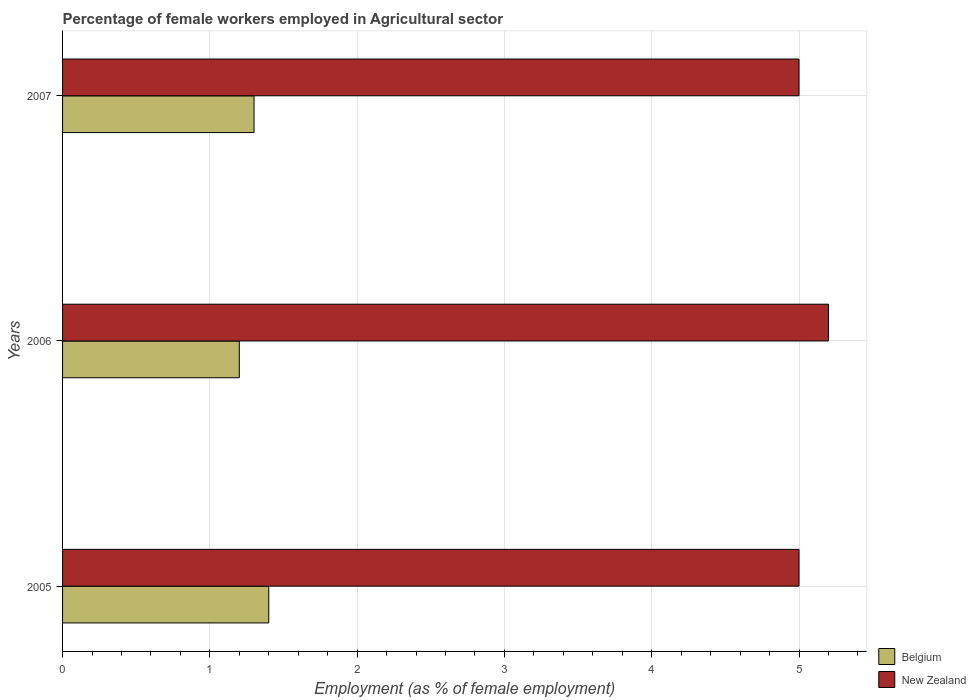How many groups of bars are there?
Keep it short and to the point. 3. Are the number of bars per tick equal to the number of legend labels?
Your answer should be very brief. Yes. Are the number of bars on each tick of the Y-axis equal?
Your answer should be compact. Yes. What is the label of the 1st group of bars from the top?
Offer a terse response. 2007. In how many cases, is the number of bars for a given year not equal to the number of legend labels?
Your answer should be very brief. 0. What is the percentage of females employed in Agricultural sector in Belgium in 2007?
Provide a succinct answer. 1.3. Across all years, what is the maximum percentage of females employed in Agricultural sector in New Zealand?
Your answer should be very brief. 5.2. Across all years, what is the minimum percentage of females employed in Agricultural sector in New Zealand?
Keep it short and to the point. 5. What is the total percentage of females employed in Agricultural sector in Belgium in the graph?
Keep it short and to the point. 3.9. What is the difference between the percentage of females employed in Agricultural sector in Belgium in 2006 and that in 2007?
Make the answer very short. -0.1. What is the difference between the percentage of females employed in Agricultural sector in Belgium in 2006 and the percentage of females employed in Agricultural sector in New Zealand in 2007?
Keep it short and to the point. -3.8. What is the average percentage of females employed in Agricultural sector in Belgium per year?
Provide a short and direct response. 1.3. In the year 2005, what is the difference between the percentage of females employed in Agricultural sector in New Zealand and percentage of females employed in Agricultural sector in Belgium?
Your answer should be compact. 3.6. What is the ratio of the percentage of females employed in Agricultural sector in Belgium in 2006 to that in 2007?
Provide a short and direct response. 0.92. Is the percentage of females employed in Agricultural sector in New Zealand in 2006 less than that in 2007?
Offer a very short reply. No. Is the difference between the percentage of females employed in Agricultural sector in New Zealand in 2006 and 2007 greater than the difference between the percentage of females employed in Agricultural sector in Belgium in 2006 and 2007?
Provide a short and direct response. Yes. What is the difference between the highest and the second highest percentage of females employed in Agricultural sector in New Zealand?
Provide a succinct answer. 0.2. What is the difference between the highest and the lowest percentage of females employed in Agricultural sector in New Zealand?
Provide a short and direct response. 0.2. Is the sum of the percentage of females employed in Agricultural sector in Belgium in 2005 and 2007 greater than the maximum percentage of females employed in Agricultural sector in New Zealand across all years?
Your answer should be very brief. No. What does the 1st bar from the top in 2005 represents?
Offer a terse response. New Zealand. What does the 1st bar from the bottom in 2007 represents?
Give a very brief answer. Belgium. How many bars are there?
Provide a short and direct response. 6. Are all the bars in the graph horizontal?
Provide a succinct answer. Yes. How many years are there in the graph?
Offer a very short reply. 3. What is the difference between two consecutive major ticks on the X-axis?
Ensure brevity in your answer.  1. Does the graph contain any zero values?
Ensure brevity in your answer.  No. Where does the legend appear in the graph?
Offer a terse response. Bottom right. What is the title of the graph?
Ensure brevity in your answer.  Percentage of female workers employed in Agricultural sector. What is the label or title of the X-axis?
Your response must be concise. Employment (as % of female employment). What is the label or title of the Y-axis?
Keep it short and to the point. Years. What is the Employment (as % of female employment) of Belgium in 2005?
Your answer should be compact. 1.4. What is the Employment (as % of female employment) of New Zealand in 2005?
Offer a very short reply. 5. What is the Employment (as % of female employment) in Belgium in 2006?
Give a very brief answer. 1.2. What is the Employment (as % of female employment) in New Zealand in 2006?
Offer a terse response. 5.2. What is the Employment (as % of female employment) in Belgium in 2007?
Make the answer very short. 1.3. Across all years, what is the maximum Employment (as % of female employment) of Belgium?
Your answer should be compact. 1.4. Across all years, what is the maximum Employment (as % of female employment) in New Zealand?
Ensure brevity in your answer.  5.2. Across all years, what is the minimum Employment (as % of female employment) of Belgium?
Your answer should be compact. 1.2. What is the total Employment (as % of female employment) in Belgium in the graph?
Provide a succinct answer. 3.9. What is the difference between the Employment (as % of female employment) of New Zealand in 2005 and that in 2006?
Provide a short and direct response. -0.2. What is the difference between the Employment (as % of female employment) in Belgium in 2005 and that in 2007?
Give a very brief answer. 0.1. What is the difference between the Employment (as % of female employment) in New Zealand in 2005 and that in 2007?
Your response must be concise. 0. What is the difference between the Employment (as % of female employment) in New Zealand in 2006 and that in 2007?
Ensure brevity in your answer.  0.2. What is the difference between the Employment (as % of female employment) in Belgium in 2005 and the Employment (as % of female employment) in New Zealand in 2007?
Give a very brief answer. -3.6. What is the difference between the Employment (as % of female employment) of Belgium in 2006 and the Employment (as % of female employment) of New Zealand in 2007?
Your response must be concise. -3.8. What is the average Employment (as % of female employment) of Belgium per year?
Keep it short and to the point. 1.3. What is the average Employment (as % of female employment) of New Zealand per year?
Your answer should be compact. 5.07. In the year 2005, what is the difference between the Employment (as % of female employment) in Belgium and Employment (as % of female employment) in New Zealand?
Your answer should be compact. -3.6. In the year 2006, what is the difference between the Employment (as % of female employment) in Belgium and Employment (as % of female employment) in New Zealand?
Provide a succinct answer. -4. What is the ratio of the Employment (as % of female employment) in New Zealand in 2005 to that in 2006?
Your answer should be very brief. 0.96. What is the ratio of the Employment (as % of female employment) of Belgium in 2005 to that in 2007?
Offer a very short reply. 1.08. What is the ratio of the Employment (as % of female employment) of New Zealand in 2005 to that in 2007?
Your answer should be very brief. 1. What is the ratio of the Employment (as % of female employment) of New Zealand in 2006 to that in 2007?
Offer a very short reply. 1.04. What is the difference between the highest and the lowest Employment (as % of female employment) of New Zealand?
Provide a short and direct response. 0.2. 